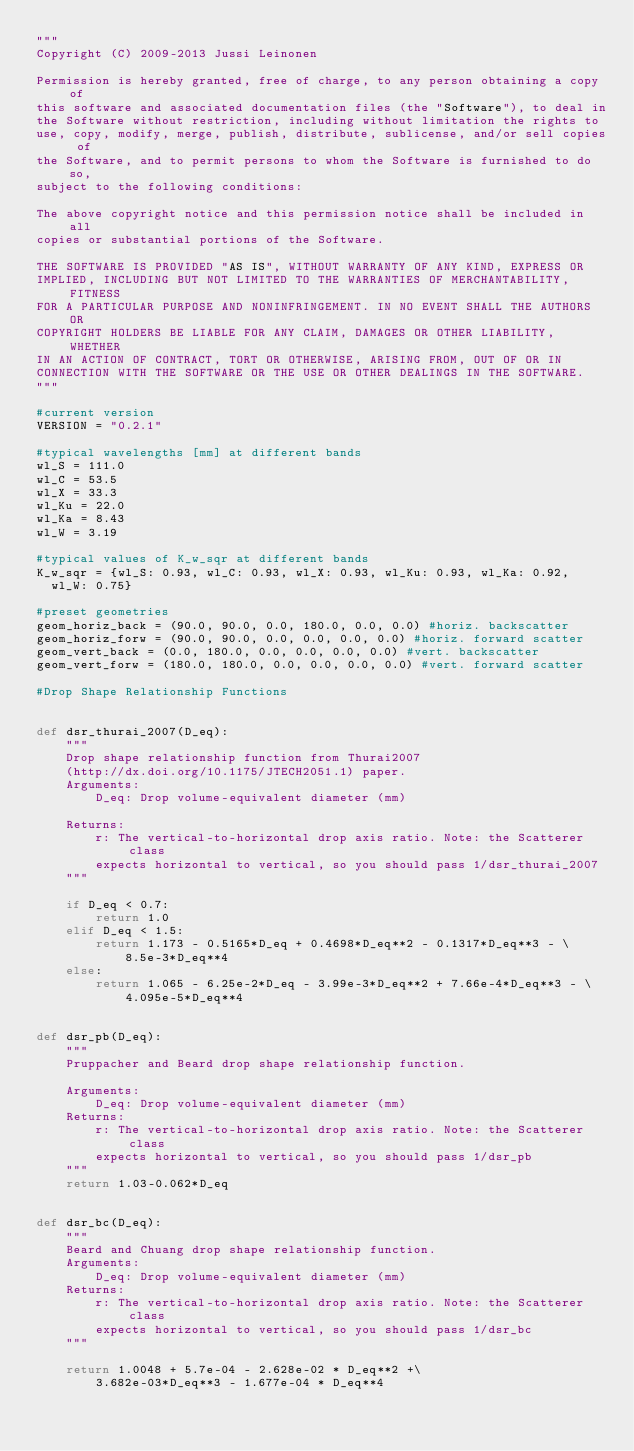<code> <loc_0><loc_0><loc_500><loc_500><_Python_>"""
Copyright (C) 2009-2013 Jussi Leinonen

Permission is hereby granted, free of charge, to any person obtaining a copy of
this software and associated documentation files (the "Software"), to deal in
the Software without restriction, including without limitation the rights to
use, copy, modify, merge, publish, distribute, sublicense, and/or sell copies of
the Software, and to permit persons to whom the Software is furnished to do so,
subject to the following conditions:

The above copyright notice and this permission notice shall be included in all
copies or substantial portions of the Software.

THE SOFTWARE IS PROVIDED "AS IS", WITHOUT WARRANTY OF ANY KIND, EXPRESS OR
IMPLIED, INCLUDING BUT NOT LIMITED TO THE WARRANTIES OF MERCHANTABILITY, FITNESS
FOR A PARTICULAR PURPOSE AND NONINFRINGEMENT. IN NO EVENT SHALL THE AUTHORS OR
COPYRIGHT HOLDERS BE LIABLE FOR ANY CLAIM, DAMAGES OR OTHER LIABILITY, WHETHER
IN AN ACTION OF CONTRACT, TORT OR OTHERWISE, ARISING FROM, OUT OF OR IN
CONNECTION WITH THE SOFTWARE OR THE USE OR OTHER DEALINGS IN THE SOFTWARE.
"""

#current version
VERSION = "0.2.1"

#typical wavelengths [mm] at different bands
wl_S = 111.0
wl_C = 53.5
wl_X = 33.3
wl_Ku = 22.0
wl_Ka = 8.43
wl_W = 3.19

#typical values of K_w_sqr at different bands
K_w_sqr = {wl_S: 0.93, wl_C: 0.93, wl_X: 0.93, wl_Ku: 0.93, wl_Ka: 0.92, 
  wl_W: 0.75}

#preset geometries
geom_horiz_back = (90.0, 90.0, 0.0, 180.0, 0.0, 0.0) #horiz. backscatter
geom_horiz_forw = (90.0, 90.0, 0.0, 0.0, 0.0, 0.0) #horiz. forward scatter
geom_vert_back = (0.0, 180.0, 0.0, 0.0, 0.0, 0.0) #vert. backscatter
geom_vert_forw = (180.0, 180.0, 0.0, 0.0, 0.0, 0.0) #vert. forward scatter

#Drop Shape Relationship Functions


def dsr_thurai_2007(D_eq):
    """
    Drop shape relationship function from Thurai2007
    (http://dx.doi.org/10.1175/JTECH2051.1) paper.
    Arguments:
        D_eq: Drop volume-equivalent diameter (mm)

    Returns:
        r: The vertical-to-horizontal drop axis ratio. Note: the Scatterer class
        expects horizontal to vertical, so you should pass 1/dsr_thurai_2007
    """

    if D_eq < 0.7:
        return 1.0
    elif D_eq < 1.5:
        return 1.173 - 0.5165*D_eq + 0.4698*D_eq**2 - 0.1317*D_eq**3 - \
            8.5e-3*D_eq**4
    else:
        return 1.065 - 6.25e-2*D_eq - 3.99e-3*D_eq**2 + 7.66e-4*D_eq**3 - \
            4.095e-5*D_eq**4


def dsr_pb(D_eq):
    """
    Pruppacher and Beard drop shape relationship function.

    Arguments:
        D_eq: Drop volume-equivalent diameter (mm)
    Returns:
        r: The vertical-to-horizontal drop axis ratio. Note: the Scatterer class
        expects horizontal to vertical, so you should pass 1/dsr_pb
    """
    return 1.03-0.062*D_eq


def dsr_bc(D_eq):
    """
    Beard and Chuang drop shape relationship function.
    Arguments:
        D_eq: Drop volume-equivalent diameter (mm)
    Returns:
        r: The vertical-to-horizontal drop axis ratio. Note: the Scatterer class
        expects horizontal to vertical, so you should pass 1/dsr_bc
    """

    return 1.0048 + 5.7e-04 - 2.628e-02 * D_eq**2 +\
        3.682e-03*D_eq**3 - 1.677e-04 * D_eq**4
</code> 